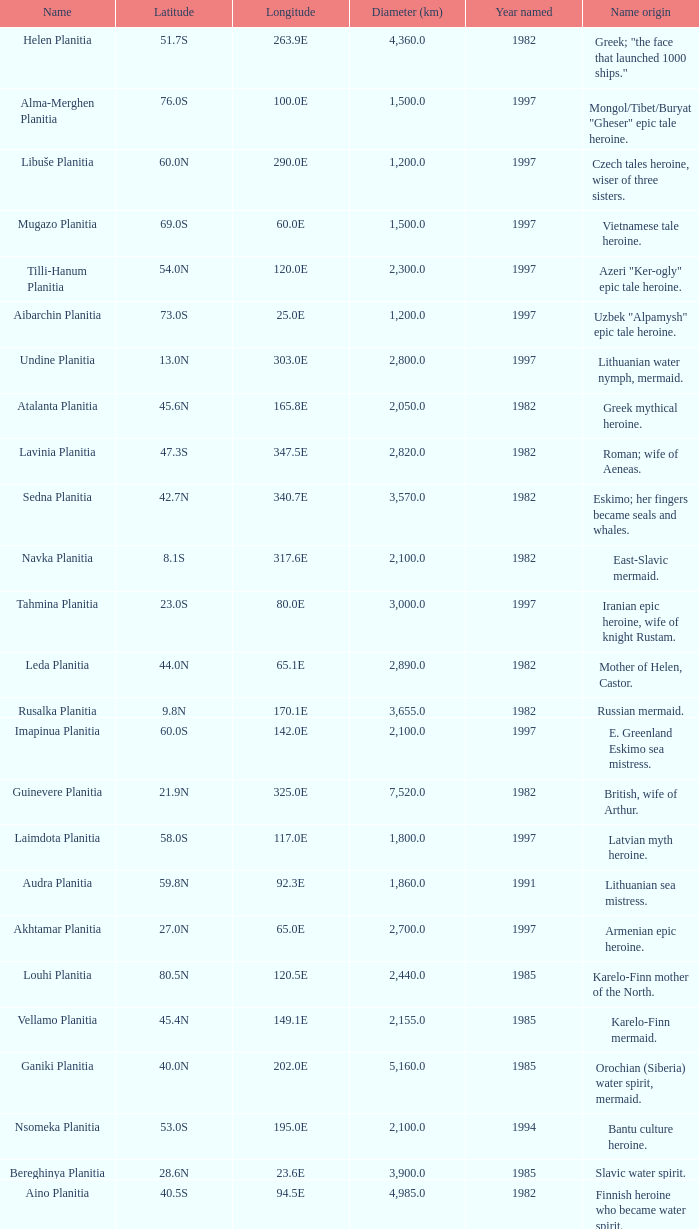What is the diameter (km) of longitude 170.1e 3655.0. 